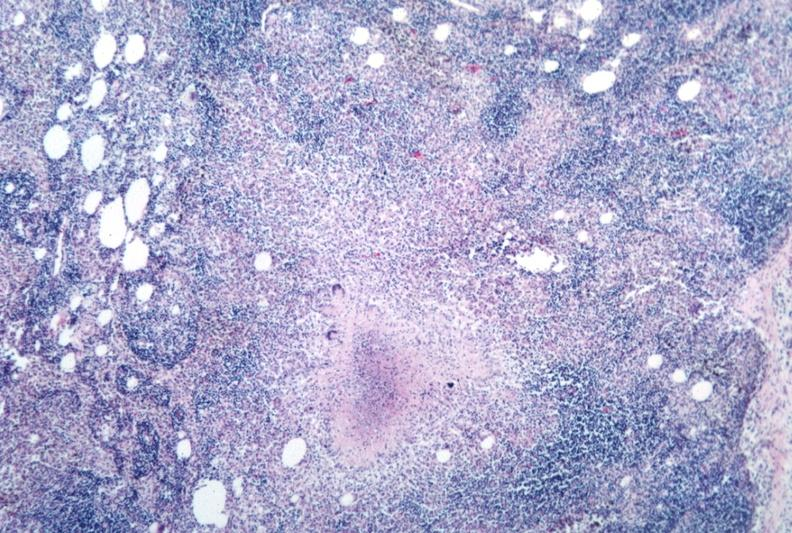does interesting case show necrotizing granuloma?
Answer the question using a single word or phrase. No 